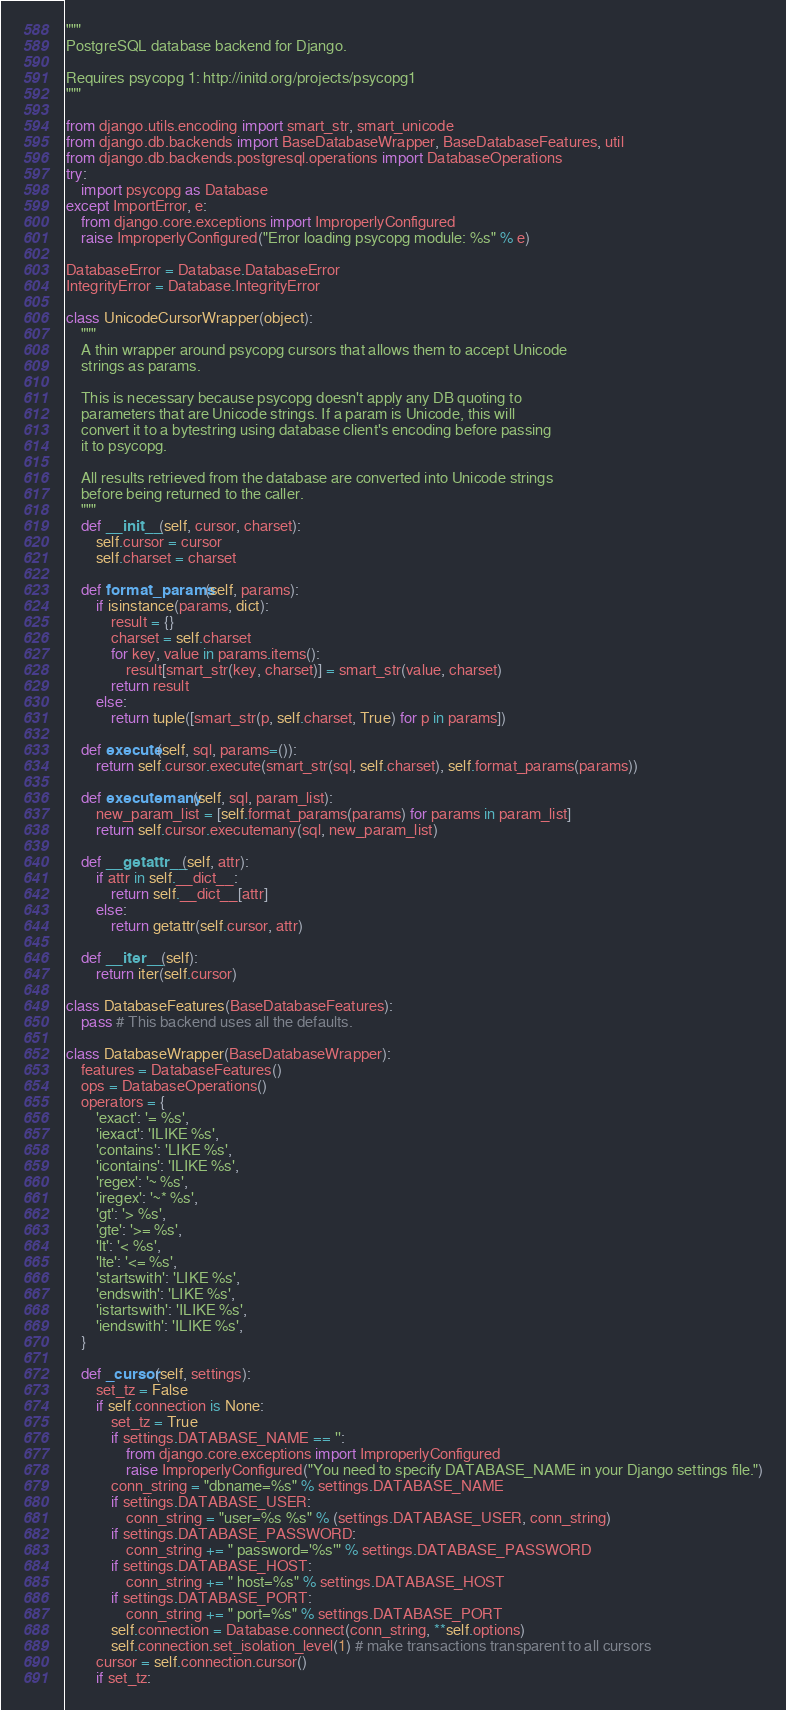Convert code to text. <code><loc_0><loc_0><loc_500><loc_500><_Python_>"""
PostgreSQL database backend for Django.

Requires psycopg 1: http://initd.org/projects/psycopg1
"""

from django.utils.encoding import smart_str, smart_unicode
from django.db.backends import BaseDatabaseWrapper, BaseDatabaseFeatures, util
from django.db.backends.postgresql.operations import DatabaseOperations
try:
    import psycopg as Database
except ImportError, e:
    from django.core.exceptions import ImproperlyConfigured
    raise ImproperlyConfigured("Error loading psycopg module: %s" % e)

DatabaseError = Database.DatabaseError
IntegrityError = Database.IntegrityError

class UnicodeCursorWrapper(object):
    """
    A thin wrapper around psycopg cursors that allows them to accept Unicode
    strings as params.

    This is necessary because psycopg doesn't apply any DB quoting to
    parameters that are Unicode strings. If a param is Unicode, this will
    convert it to a bytestring using database client's encoding before passing
    it to psycopg.

    All results retrieved from the database are converted into Unicode strings
    before being returned to the caller.
    """
    def __init__(self, cursor, charset):
        self.cursor = cursor
        self.charset = charset

    def format_params(self, params):
        if isinstance(params, dict):
            result = {}
            charset = self.charset
            for key, value in params.items():
                result[smart_str(key, charset)] = smart_str(value, charset)
            return result
        else:
            return tuple([smart_str(p, self.charset, True) for p in params])

    def execute(self, sql, params=()):
        return self.cursor.execute(smart_str(sql, self.charset), self.format_params(params))

    def executemany(self, sql, param_list):
        new_param_list = [self.format_params(params) for params in param_list]
        return self.cursor.executemany(sql, new_param_list)

    def __getattr__(self, attr):
        if attr in self.__dict__:
            return self.__dict__[attr]
        else:
            return getattr(self.cursor, attr)

    def __iter__(self):
        return iter(self.cursor)

class DatabaseFeatures(BaseDatabaseFeatures):
    pass # This backend uses all the defaults.

class DatabaseWrapper(BaseDatabaseWrapper):
    features = DatabaseFeatures()
    ops = DatabaseOperations()
    operators = {
        'exact': '= %s',
        'iexact': 'ILIKE %s',
        'contains': 'LIKE %s',
        'icontains': 'ILIKE %s',
        'regex': '~ %s',
        'iregex': '~* %s',
        'gt': '> %s',
        'gte': '>= %s',
        'lt': '< %s',
        'lte': '<= %s',
        'startswith': 'LIKE %s',
        'endswith': 'LIKE %s',
        'istartswith': 'ILIKE %s',
        'iendswith': 'ILIKE %s',
    }

    def _cursor(self, settings):
        set_tz = False
        if self.connection is None:
            set_tz = True
            if settings.DATABASE_NAME == '':
                from django.core.exceptions import ImproperlyConfigured
                raise ImproperlyConfigured("You need to specify DATABASE_NAME in your Django settings file.")
            conn_string = "dbname=%s" % settings.DATABASE_NAME
            if settings.DATABASE_USER:
                conn_string = "user=%s %s" % (settings.DATABASE_USER, conn_string)
            if settings.DATABASE_PASSWORD:
                conn_string += " password='%s'" % settings.DATABASE_PASSWORD
            if settings.DATABASE_HOST:
                conn_string += " host=%s" % settings.DATABASE_HOST
            if settings.DATABASE_PORT:
                conn_string += " port=%s" % settings.DATABASE_PORT
            self.connection = Database.connect(conn_string, **self.options)
            self.connection.set_isolation_level(1) # make transactions transparent to all cursors
        cursor = self.connection.cursor()
        if set_tz:</code> 